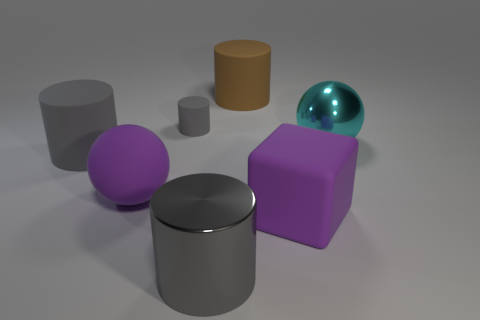Do the big gray cylinder in front of the large purple matte ball and the gray cylinder behind the cyan shiny ball have the same material?
Keep it short and to the point. No. There is a metallic thing that is the same size as the metallic cylinder; what is its shape?
Give a very brief answer. Sphere. How many other objects are the same color as the tiny rubber thing?
Your response must be concise. 2. How many cyan things are either tiny cylinders or matte cylinders?
Keep it short and to the point. 0. Do the large rubber thing behind the large gray rubber thing and the large shiny thing behind the gray metal cylinder have the same shape?
Provide a succinct answer. No. How many other objects are the same material as the block?
Provide a short and direct response. 4. There is a purple thing that is on the left side of the big rubber cylinder that is behind the cyan ball; is there a rubber thing that is in front of it?
Your answer should be compact. Yes. Do the small thing and the brown cylinder have the same material?
Provide a short and direct response. Yes. Are there any other things that have the same shape as the cyan shiny object?
Your response must be concise. Yes. What material is the big thing that is to the left of the large purple thing behind the purple matte block?
Offer a very short reply. Rubber. 